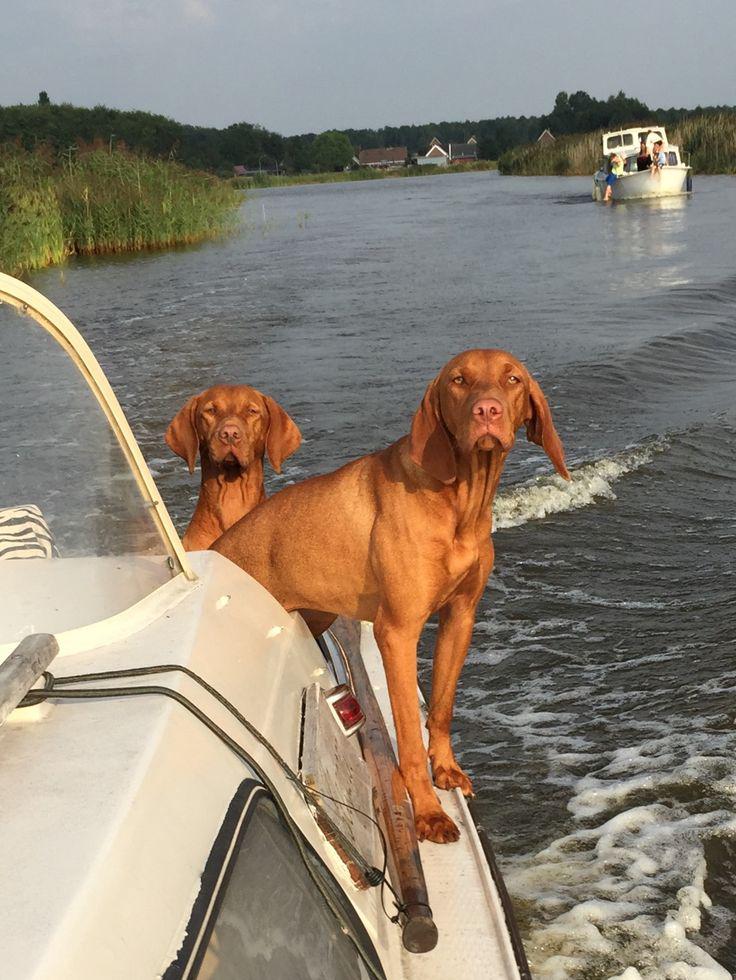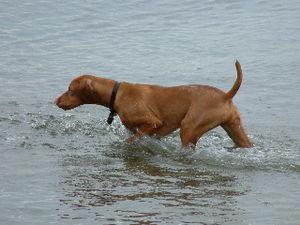The first image is the image on the left, the second image is the image on the right. For the images shown, is this caption "One red-orange dog is splashing through the water in one image, and the other image features at least one red-orange dog on a surface above the water." true? Answer yes or no. Yes. The first image is the image on the left, the second image is the image on the right. Considering the images on both sides, is "The left image contains at least two dogs." valid? Answer yes or no. Yes. 